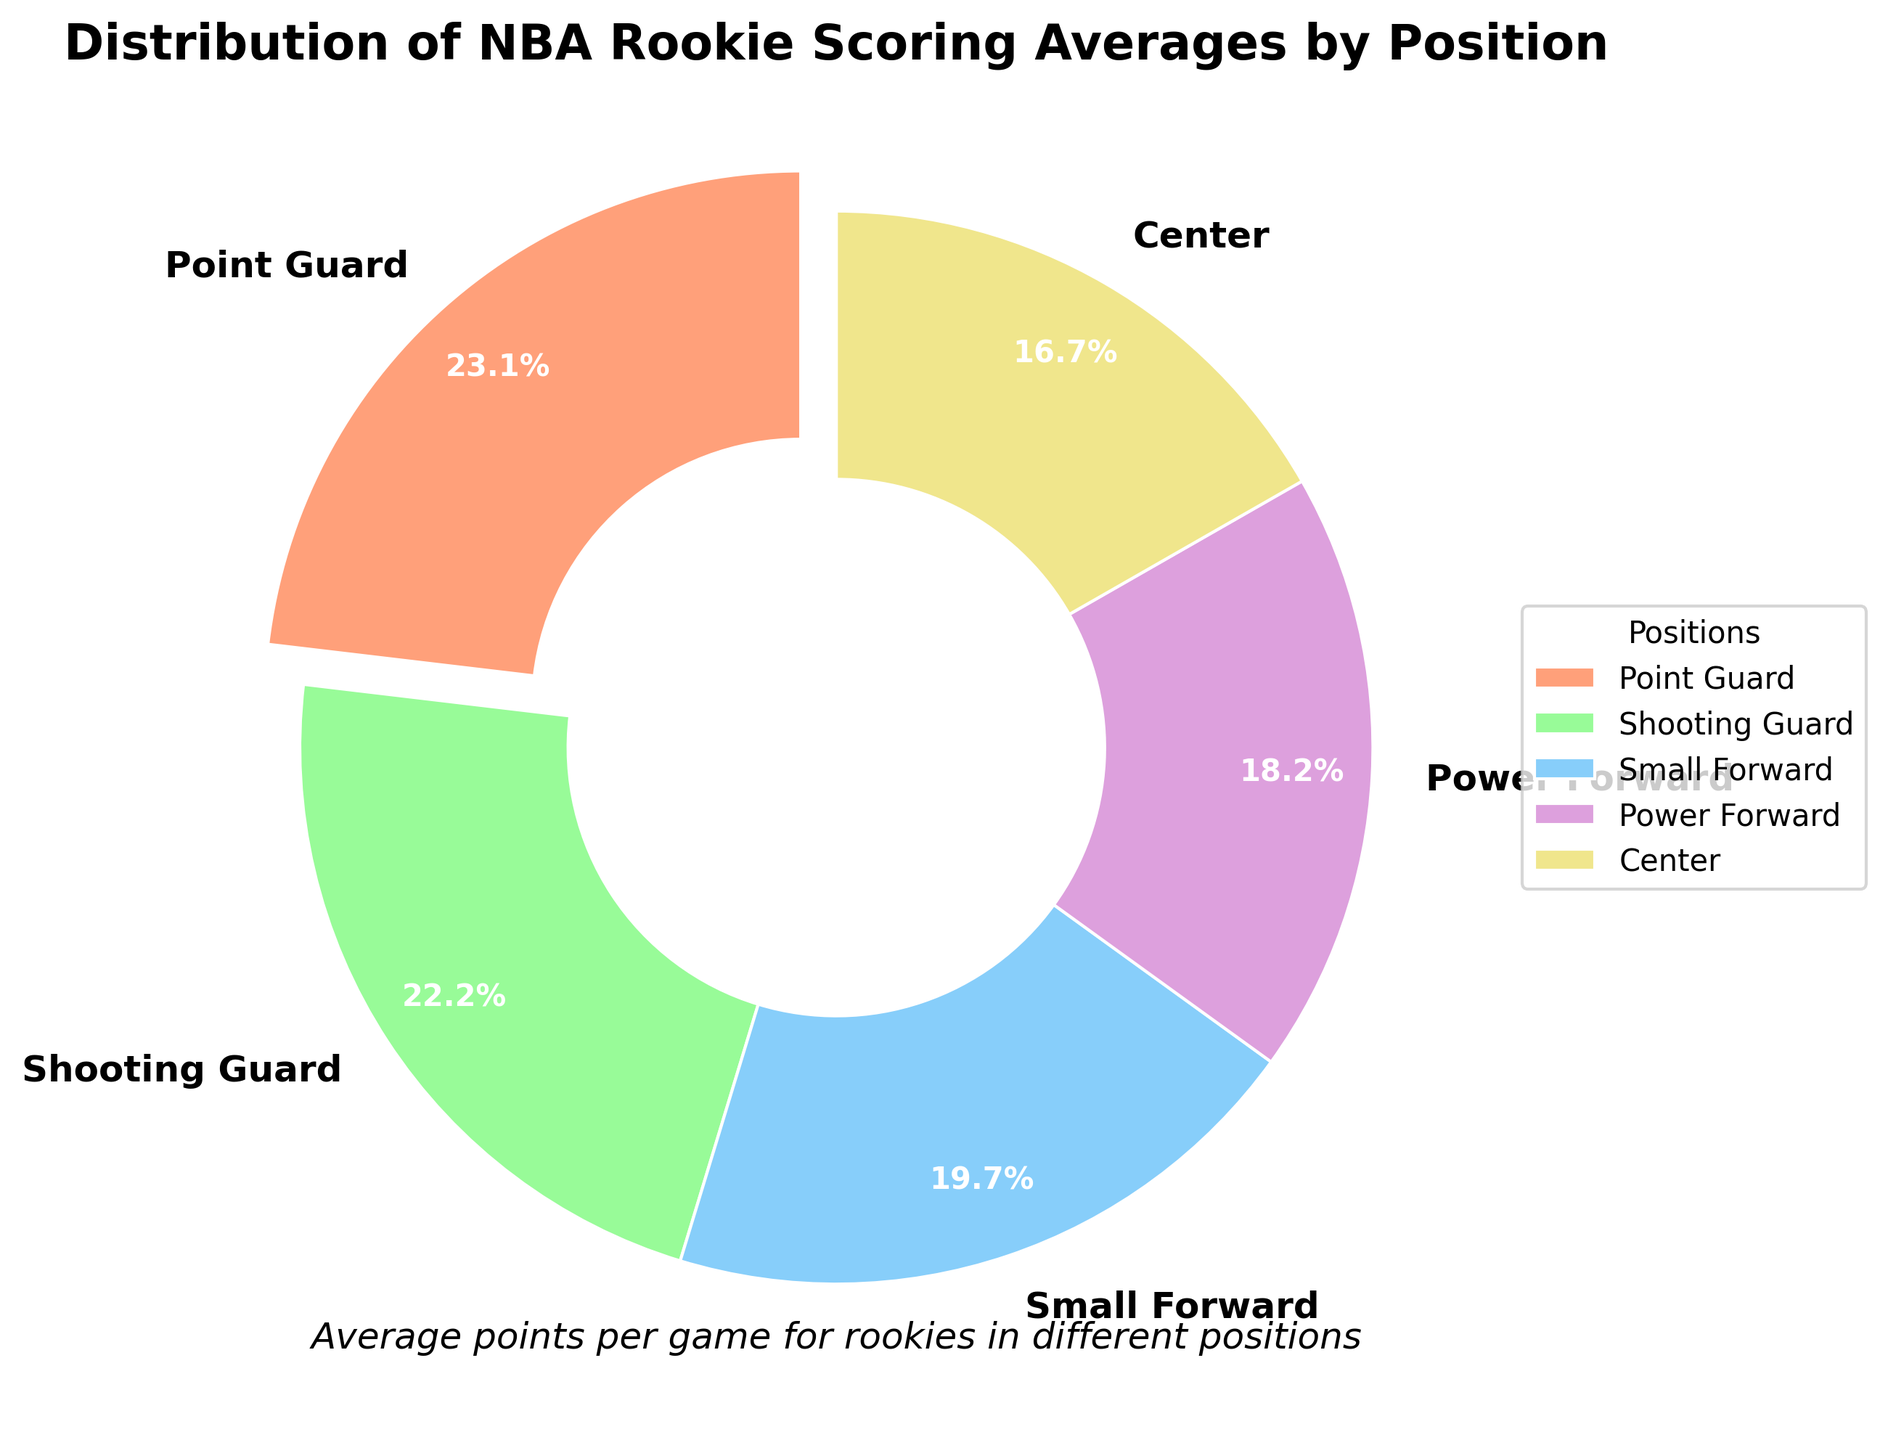Which position has the highest average scoring for NBA rookies? The pie chart shows the average scoring for different positions. The position with the highest percentage will have the highest average scoring. Point Guard has the highest percentage in the chart.
Answer: Point Guard Which position has the lowest average scoring for NBA rookies? The pie chart shows the average scoring for different positions. The position with the lowest percentage will have the lowest average scoring. Center has the smallest percentage in the chart.
Answer: Center What is the combined average scoring for Small Forward and Power Forward rookies? Add the average scoring for Small Forward and Power Forward from the chart: 10.5 (Small Forward) + 9.7 (Power Forward) = 20.2
Answer: 20.2 Which two positions contribute to nearly half of the total rookie scoring? Look at the wedges with the highest percentages and add them. The two largest wedges are Point Guard (12.3) and Shooting Guard (11.8). Their combined contribution is 12.3 + 11.8 = 24.1, which is slightly under half the total.
Answer: Point Guard and Shooting Guard What's the difference in average scoring between Shooting Guard and Center rookies? Subtract the average scoring of Center from Shooting Guard: 11.8 (Shooting Guard) - 8.9 (Center) = 2.9
Answer: 2.9 How does the average scoring of Power Forward compare to Point Guard? Compare the average scoring values. Point Guard has an average scoring of 12.3, while Power Forward has an average scoring of 9.7. Point Guard scores more.
Answer: Point Guard scores more How much less does Small Forward score compared to Point Guard rookies? Subtract the average scoring of Small Forward from Point Guard: 12.3 (Point Guard) - 10.5 (Small Forward) = 1.8
Answer: 1.8 What is the visual attribute used to highlight the Point Guard wedge in the pie chart? The pie chart uses an exploded slice to highlight the Point Guard wedge. It is the only slice separated from the rest, indicating emphasis.
Answer: Exploded slice 